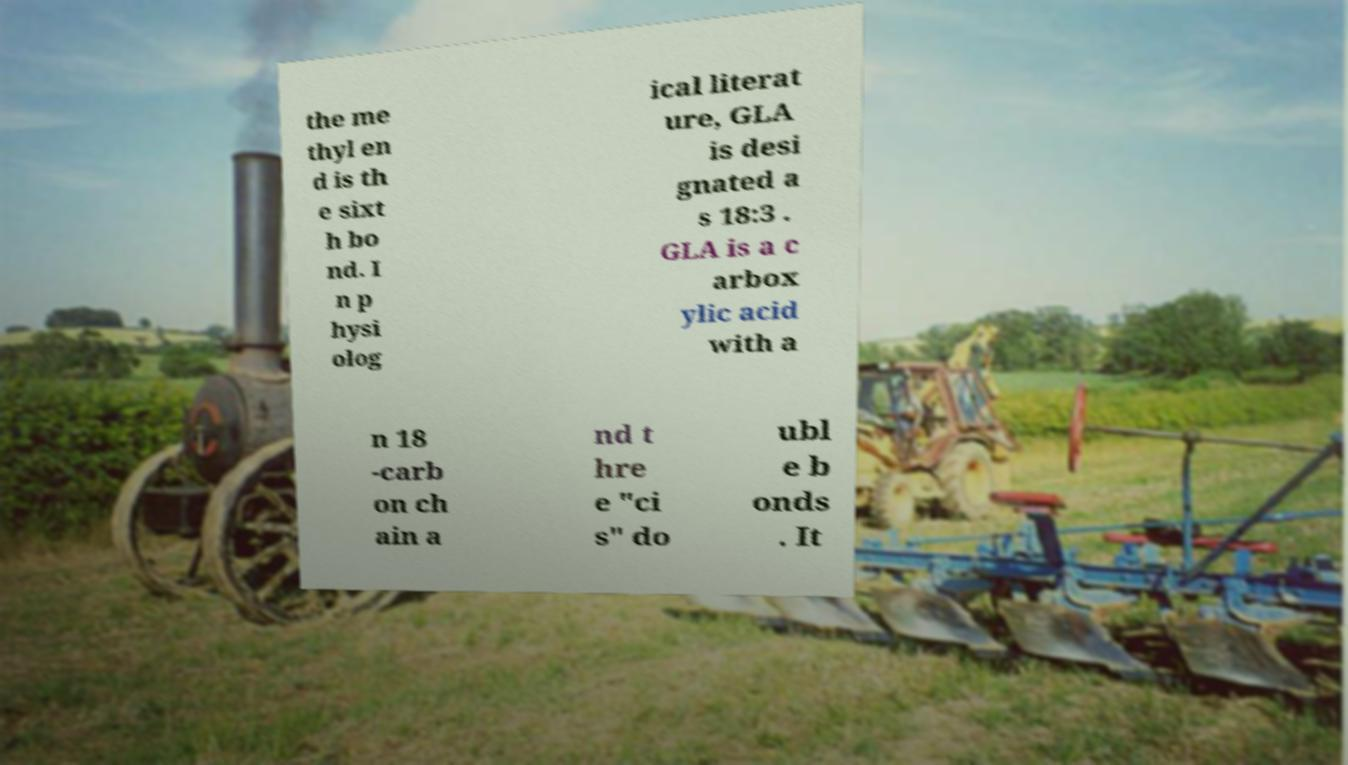For documentation purposes, I need the text within this image transcribed. Could you provide that? the me thyl en d is th e sixt h bo nd. I n p hysi olog ical literat ure, GLA is desi gnated a s 18:3 . GLA is a c arbox ylic acid with a n 18 -carb on ch ain a nd t hre e "ci s" do ubl e b onds . It 